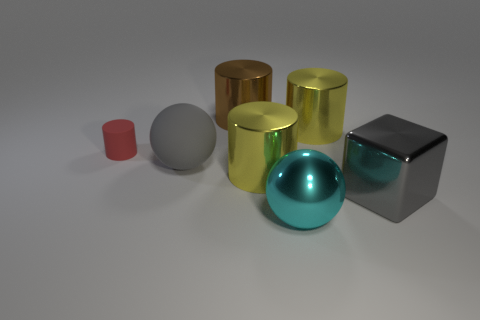Is the matte sphere the same size as the red thing?
Your answer should be very brief. No. There is a rubber object that is on the right side of the cylinder left of the big brown cylinder; what is its color?
Give a very brief answer. Gray. What color is the tiny rubber thing?
Offer a terse response. Red. Is there a tiny matte object of the same color as the large rubber object?
Give a very brief answer. No. Does the ball that is right of the large brown cylinder have the same color as the small rubber cylinder?
Offer a terse response. No. How many objects are big things that are on the left side of the gray cube or yellow metal spheres?
Offer a very short reply. 5. There is a gray block; are there any large gray metal blocks to the right of it?
Keep it short and to the point. No. There is a large sphere that is the same color as the metal block; what is its material?
Provide a succinct answer. Rubber. Do the big sphere in front of the large gray sphere and the small thing have the same material?
Offer a terse response. No. Are there any small red matte things in front of the yellow metal thing in front of the big object that is on the left side of the brown cylinder?
Ensure brevity in your answer.  No. 